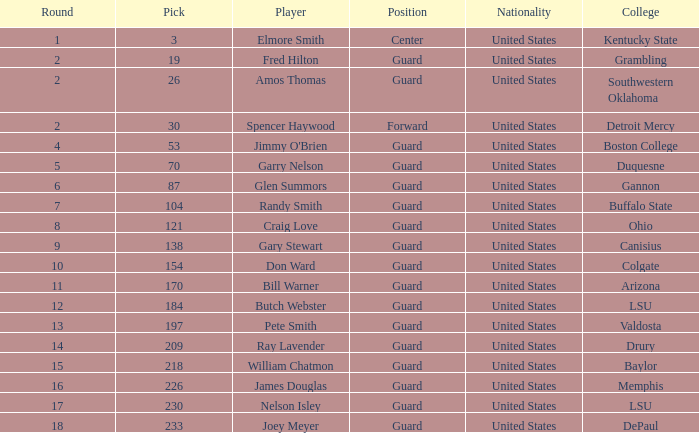What educational institution has a circular shape exceeding 9, including butch webster? LSU. 